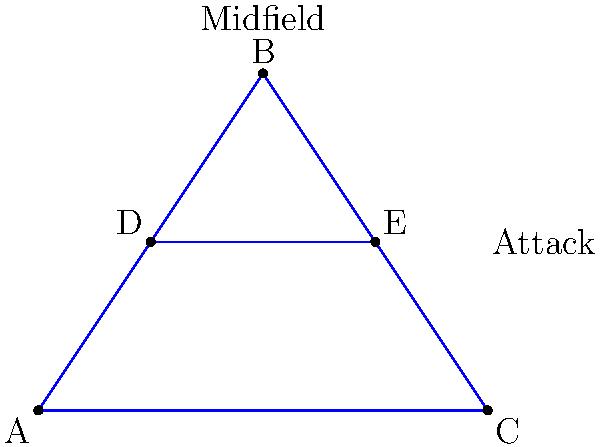In the tiki-taka style of play, passing triangles are crucial. The diagram shows a soccer field with five key positions (A, B, C, D, E) forming passing triangles. If we consider each unique triangle as an element of a group, and the operation is rotating the triangle, what is the order of the subgroup formed by the triangles that include point B? To solve this problem, let's follow these steps:

1. Identify all possible triangles that include point B:
   - Triangle ABD
   - Triangle ABE
   - Triangle ABC
   - Triangle BDE

2. For each triangle, determine the number of unique rotations:
   - Each triangle has 3 possible rotations (120° each)
   - The identity rotation (0°) is also counted

3. Calculate the total number of elements in the subgroup:
   - Number of triangles including B: 4
   - Number of rotations for each triangle: 3 + 1 = 4
   - Total elements: 4 * 4 = 16

4. Verify that this forms a subgroup:
   - It includes the identity element (no rotation)
   - It's closed under the rotation operation
   - Each element has an inverse (rotating back)
   - The operation is associative

5. The order of a group is the number of elements it contains.

Therefore, the order of the subgroup formed by the triangles that include point B is 16.
Answer: 16 